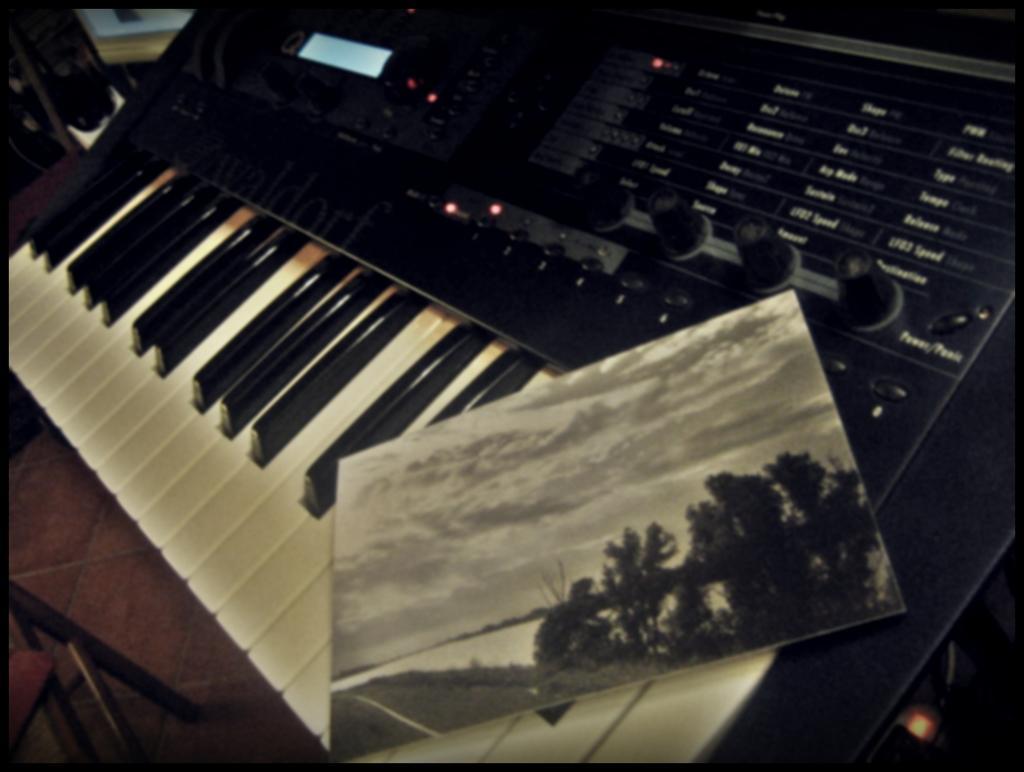How would you summarize this image in a sentence or two? In the image there is a musical keyboard. On musical keyboard we can also see a photo frame and a table on which a musical keyboard is placed. 